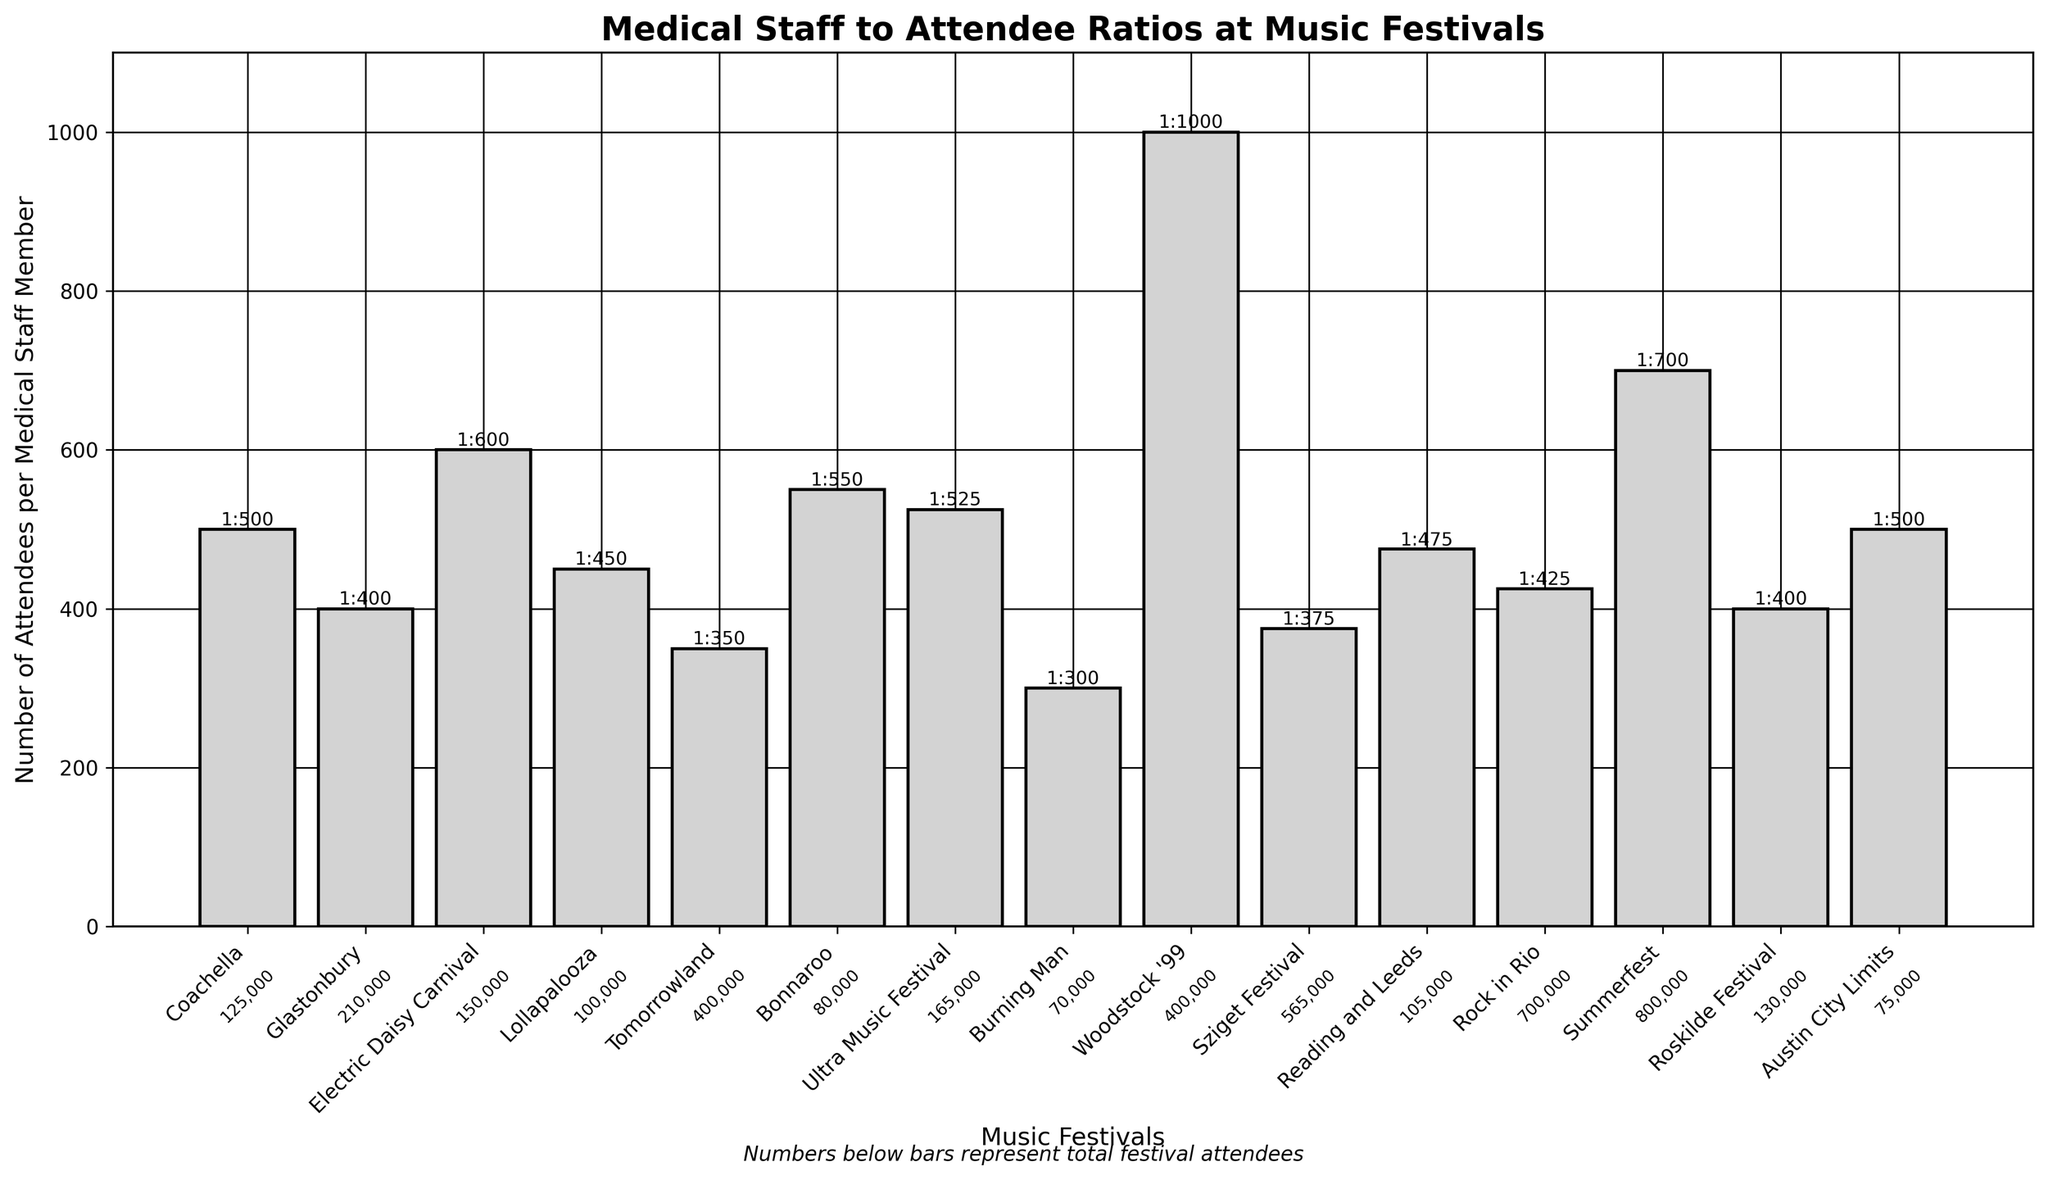Which festival has the highest number of attendees per medical staff member ratio? The festival with the highest bar in the chart represents the highest ratio. In this case, it's Woodstock '99 with a ratio of 1:1000.
Answer: Woodstock '99 What is the difference in medical staff-to-attendee ratios between Electric Daisy Carnival and Roskilde Festival? The ratios for Electric Daisy Carnival and Roskilde Festival are 1:600 and 1:400 respectively. The difference is 600 - 400 = 200 attendees per medical staff.
Answer: 200 attendees Which festival has the lowest medical staff-to-attendee ratio, and what is that ratio? The festival with the shortest bar represents the lowest ratio. In this case, it's Burning Man with a ratio of 1:300.
Answer: Burning Man, 1:300 How does the ratio at Tomorrowland compare to that at Coachella? Tomorrowland's ratio is 1:350, and Coachella's ratio is 1:500. Since 350 is less than 500, Tomorrowland has a better ratio (fewer attendees per medical staff).
Answer: Tomorrowland has a better ratio Is there a festival with a medical staff-to-attendee ratio close to 1:500? If yes, which one(s)? Coachella and Austin City Limits both have a ratio exactly of 1:500, meaning each medical staff member is responsible for 500 attendees.
Answer: Coachella, Austin City Limits What is the difference in the number of attendees between Summerfest and Rock in Rio, and what are their medical staff ratios? Summerfest has 800,000 attendees, and Rock in Rio has 700,000 attendees. The difference is 800,000 - 700,000 = 100,000 attendees. Their respective ratios are 1:700 and 1:425.
Answer: 100,000 attendees, 1:700 for Summerfest, 1:425 for Rock in Rio Considering the largest festivals (Summerfest, Rock in Rio, and Sziget Festival), what are their medical staff ratios in ascending order? The ratios are as follows: Summerfest (1:700), Rock in Rio (1:425), and Sziget Festival (1:375). Ordering them in ascending order, we get: 1:375, 1:425, 1:700.
Answer: 1:375 (Sziget Festival), 1:425 (Rock in Rio), 1:700 (Summerfest) Which festivals have more than 150,000 attendees but a higher medical staff ratio (worse) than 1:500? The festivals meeting both criteria are Electric Daisy Carnival with 150,000 attendees and a ratio of 1:600, and Summerfest with 800,000 attendees and a ratio of 1:700.
Answer: Electric Daisy Carnival, Summerfest 